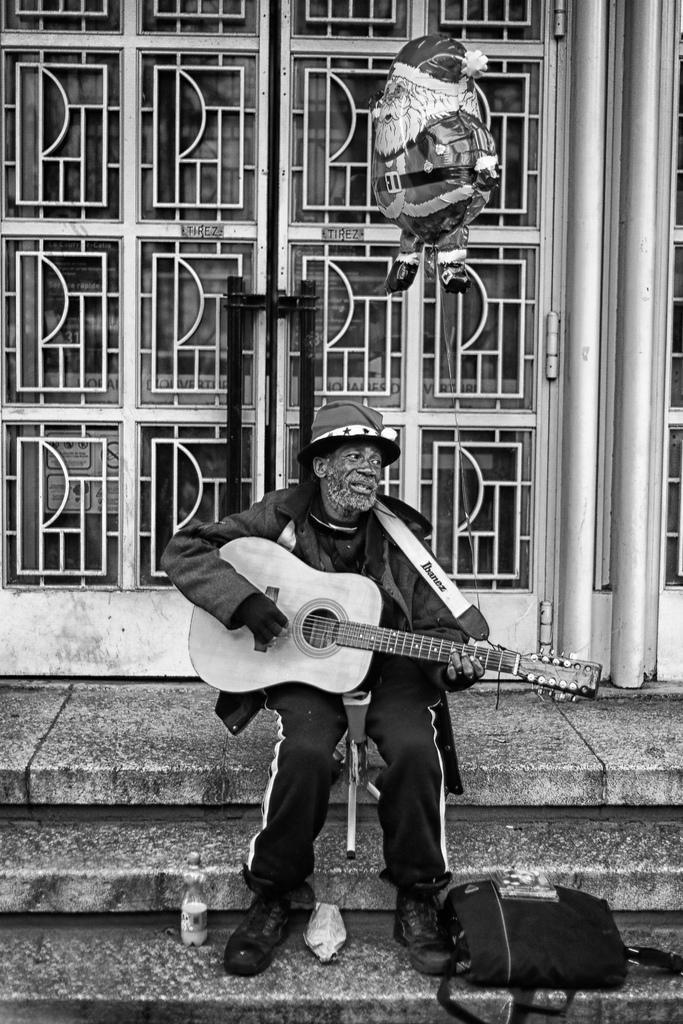Who is the main subject in the image? There is a man in the image. What is the man doing in the image? The man is sitting on the floor and playing a guitar. What else can be seen in the image besides the man? There is a bag in the image. What is visible in the background of the image? There is a door in the background of the image. What type of birthday celebration is happening in the image? There is no indication of a birthday celebration in the image; it simply shows a man playing a guitar while sitting on the floor. Can you tell me how many basketballs are visible in the image? There are no basketballs present in the image. 